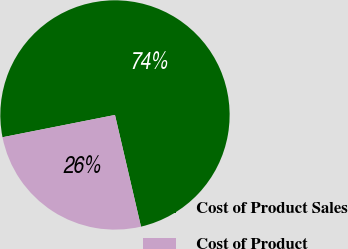Convert chart. <chart><loc_0><loc_0><loc_500><loc_500><pie_chart><fcel>Cost of Product Sales<fcel>Cost of Product<nl><fcel>74.47%<fcel>25.53%<nl></chart> 